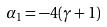<formula> <loc_0><loc_0><loc_500><loc_500>\alpha _ { 1 } = - 4 ( \gamma + 1 )</formula> 